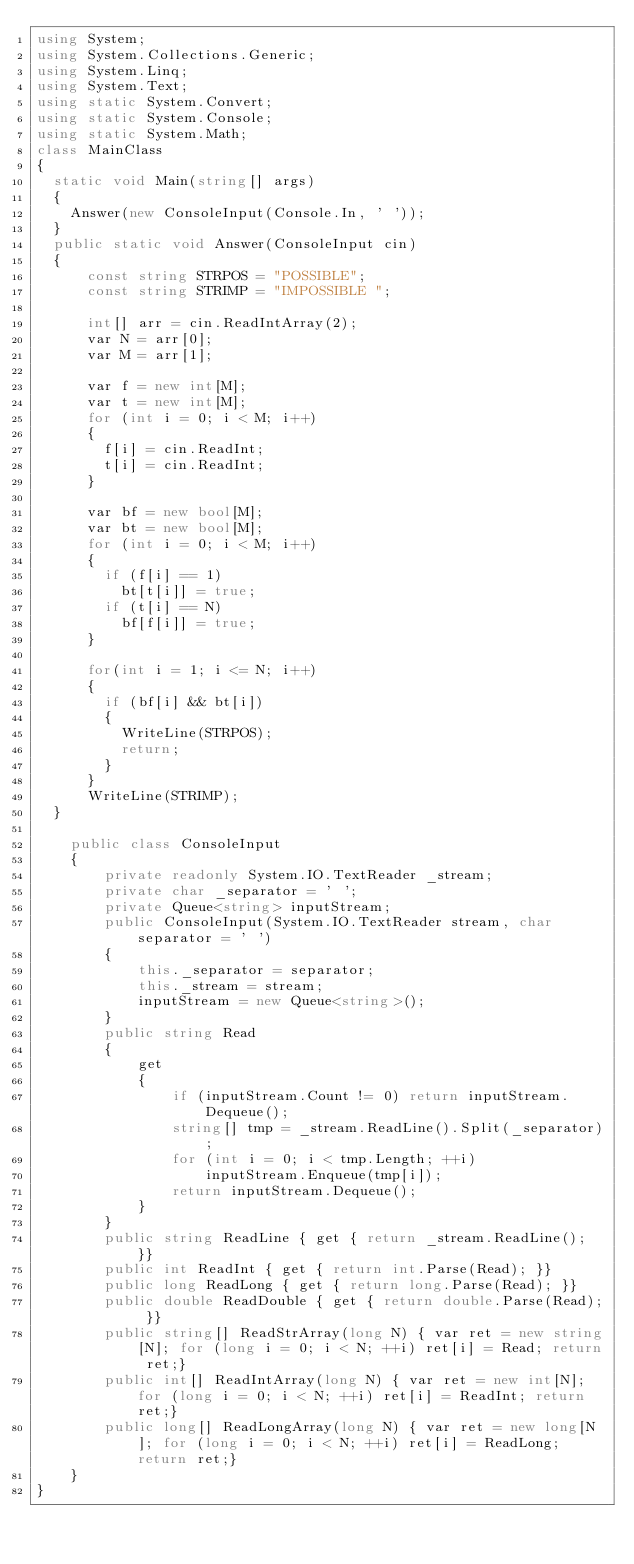Convert code to text. <code><loc_0><loc_0><loc_500><loc_500><_C#_>using System;
using System.Collections.Generic;
using System.Linq;
using System.Text;
using static System.Convert;
using static System.Console;
using static System.Math;
class MainClass
{
	static void Main(string[] args)
	{
		Answer(new ConsoleInput(Console.In, ' '));
	}
	public static void Answer(ConsoleInput cin)
	{
			const string STRPOS = "POSSIBLE";
			const string STRIMP = "IMPOSSIBLE ";

			int[] arr = cin.ReadIntArray(2);
			var N = arr[0];
			var M = arr[1];

			var f = new int[M];
			var t = new int[M];
			for (int i = 0; i < M; i++)
			{
				f[i] = cin.ReadInt;
				t[i] = cin.ReadInt;
			}

			var bf = new bool[M];
			var bt = new bool[M];
			for (int i = 0; i < M; i++)
			{
				if (f[i] == 1)
					bt[t[i]] = true;
				if (t[i] == N)
					bf[f[i]] = true;
			}

			for(int i = 1; i <= N; i++)
			{
				if (bf[i] && bt[i])
				{
					WriteLine(STRPOS);
					return;
				}
			}
			WriteLine(STRIMP);      
	}
  
    public class ConsoleInput
    {
        private readonly System.IO.TextReader _stream;
        private char _separator = ' ';
        private Queue<string> inputStream;
        public ConsoleInput(System.IO.TextReader stream, char separator = ' ')
        {
            this._separator = separator;
            this._stream = stream;
            inputStream = new Queue<string>();
        }
        public string Read
        {
            get
            {
                if (inputStream.Count != 0) return inputStream.Dequeue();
                string[] tmp = _stream.ReadLine().Split(_separator);
                for (int i = 0; i < tmp.Length; ++i)
                    inputStream.Enqueue(tmp[i]);
                return inputStream.Dequeue();
            }
        }
        public string ReadLine { get { return _stream.ReadLine(); }}
        public int ReadInt { get { return int.Parse(Read); }}
        public long ReadLong { get { return long.Parse(Read); }}
        public double ReadDouble { get { return double.Parse(Read); }}
        public string[] ReadStrArray(long N) { var ret = new string[N]; for (long i = 0; i < N; ++i) ret[i] = Read; return ret;}
        public int[] ReadIntArray(long N) { var ret = new int[N]; for (long i = 0; i < N; ++i) ret[i] = ReadInt; return ret;}
        public long[] ReadLongArray(long N) { var ret = new long[N]; for (long i = 0; i < N; ++i) ret[i] = ReadLong; return ret;}
    }
}</code> 